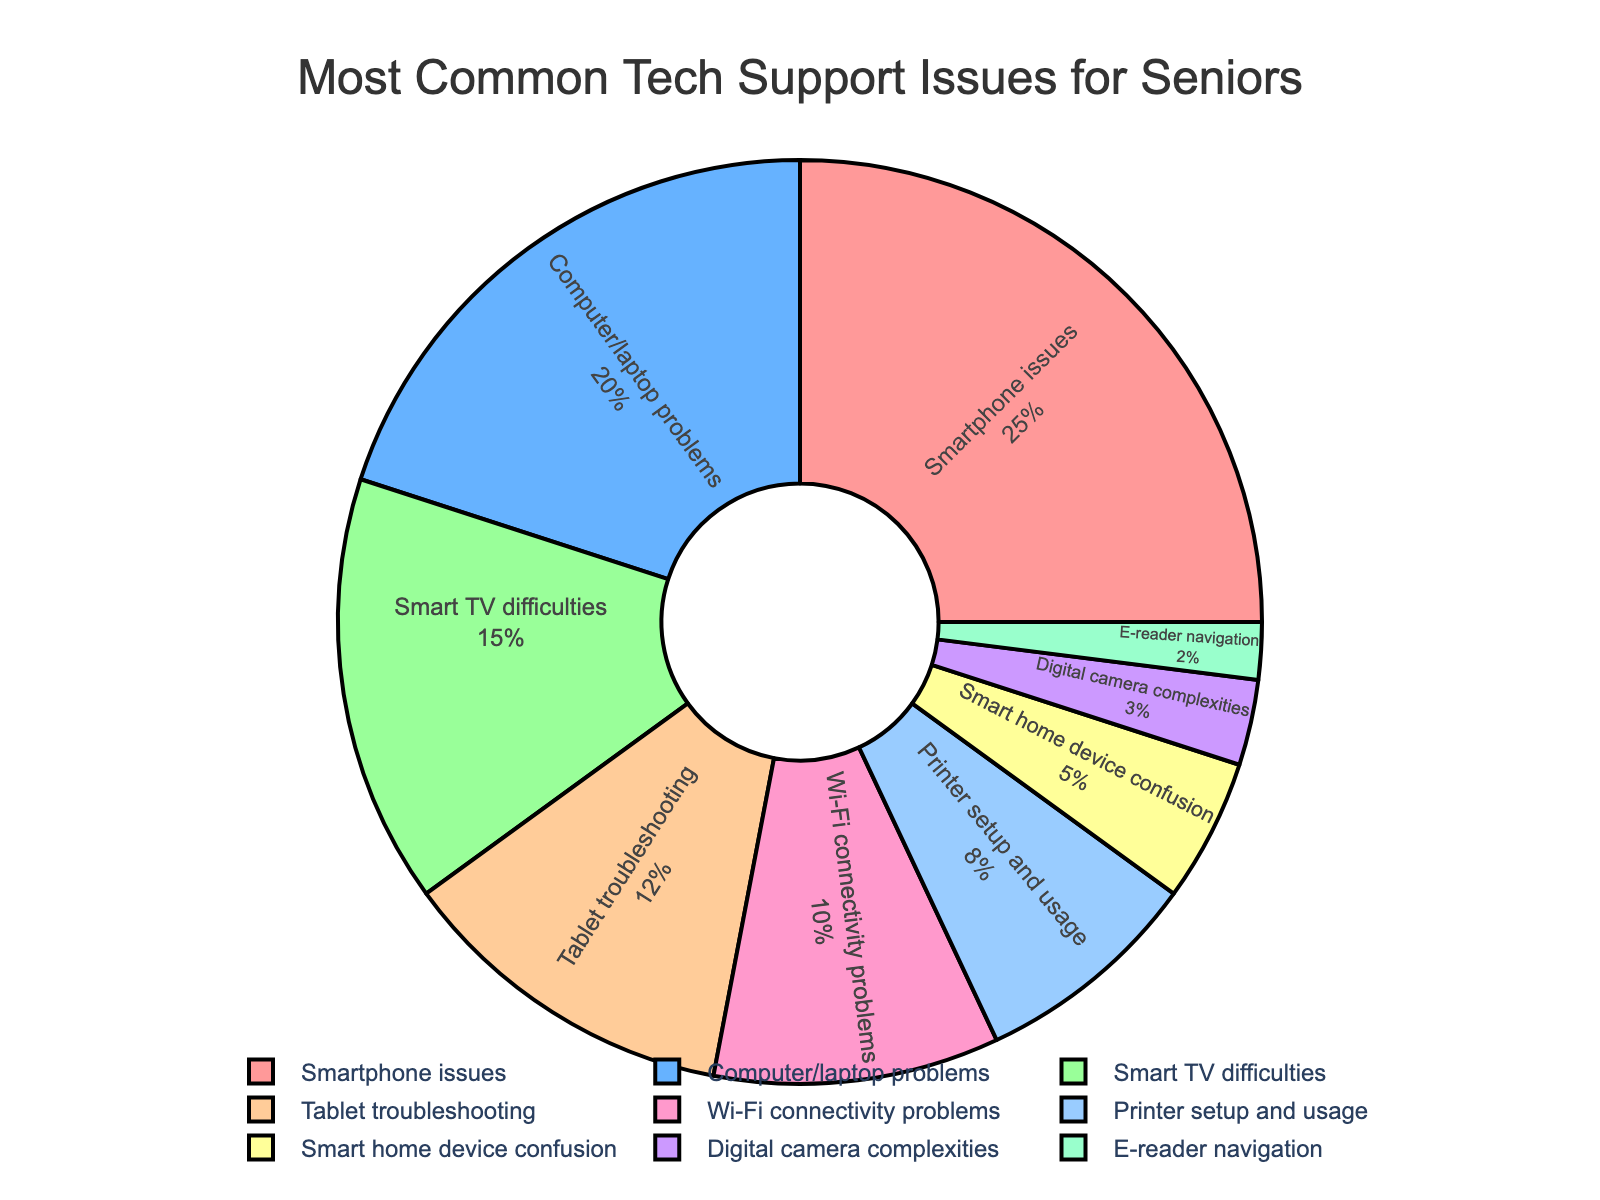What percentage of tech support issues are related to smartphones? The figure shows a pie chart labeled with device types and their corresponding percentages. Look for the slice labeled "Smartphone issues," which is noted to be 25%.
Answer: 25% Which device type accounts for the second highest percentage of tech support issues? Identify the slices of the pie chart and their percentages. The largest slice is "Smartphone issues" at 25%, followed by "Computer/laptop problems" at 20%.
Answer: Computer/laptop problems What is the combined percentage of issues related to Smart TVs and tablets? Locate the slices for "Smart TV difficulties" and "Tablet troubleshooting." Their percentages are 15% and 12% respectively. Adding these gives 15 + 12 = 27%.
Answer: 27% Is the percentage of Wi-Fi connectivity problems greater than that of printer setup and usage issues? Compare the slices labeled "Wi-Fi connectivity problems" (10%) and "Printer setup and usage" (8%).
Answer: Yes Which device type has the smallest percentage of tech support issues? Look at the pie chart to find the smallest slice. "E-reader navigation" has the smallest percentage at 2%.
Answer: E-reader navigation What is the difference in percentage between issues related to computers/laptops and Wi-Fi connectivity problems? The chart shows computers/laptops at 20% and Wi-Fi at 10%. Subtract 10 from 20 to find the difference: 20 - 10 = 10%.
Answer: 10% What percentage of tech support issues are neither smartphone-related nor computer/laptop-related? First, combine the percentages for "Smartphone issues" and "Computer/laptop problems" which are 25% and 20% respectively. This totals 45%. Subtract this from 100% to get 100 - 45 = 55%.
Answer: 55% Are more tech support issues related to smart home devices or digital cameras? Compare the segments for "Smart home device confusion" and "Digital camera complexities," which are 5% and 3% respectively.
Answer: Smart home devices 